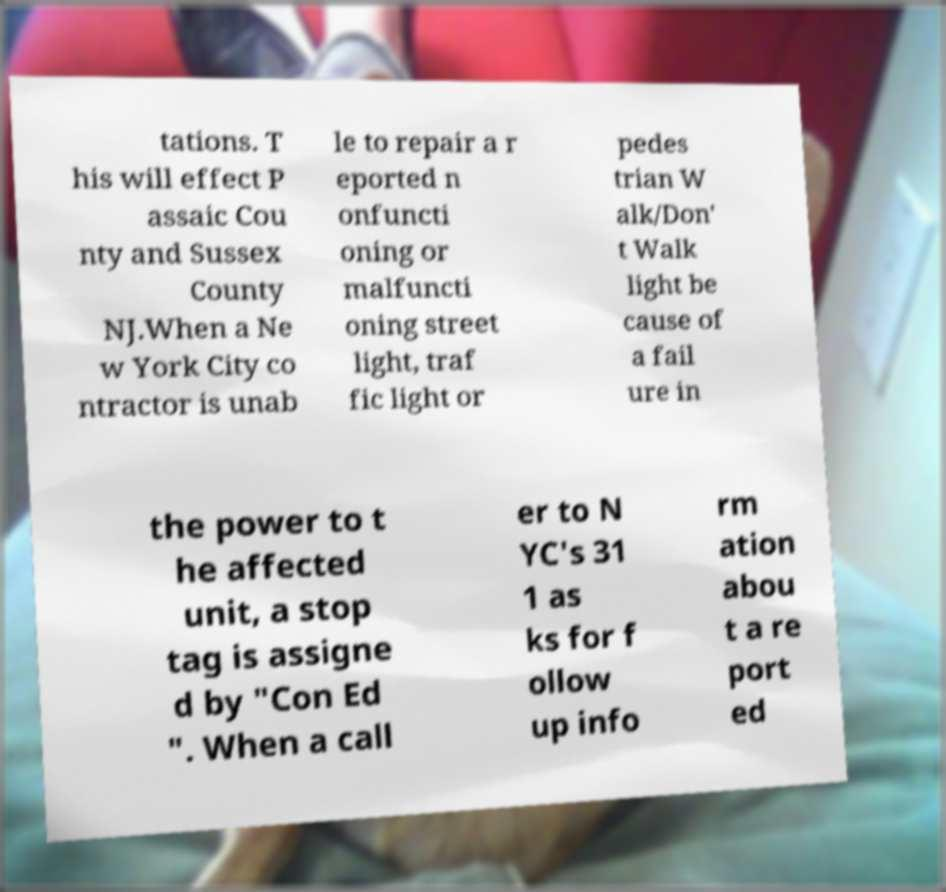Please identify and transcribe the text found in this image. tations. T his will effect P assaic Cou nty and Sussex County NJ.When a Ne w York City co ntractor is unab le to repair a r eported n onfuncti oning or malfuncti oning street light, traf fic light or pedes trian W alk/Don' t Walk light be cause of a fail ure in the power to t he affected unit, a stop tag is assigne d by "Con Ed ". When a call er to N YC's 31 1 as ks for f ollow up info rm ation abou t a re port ed 